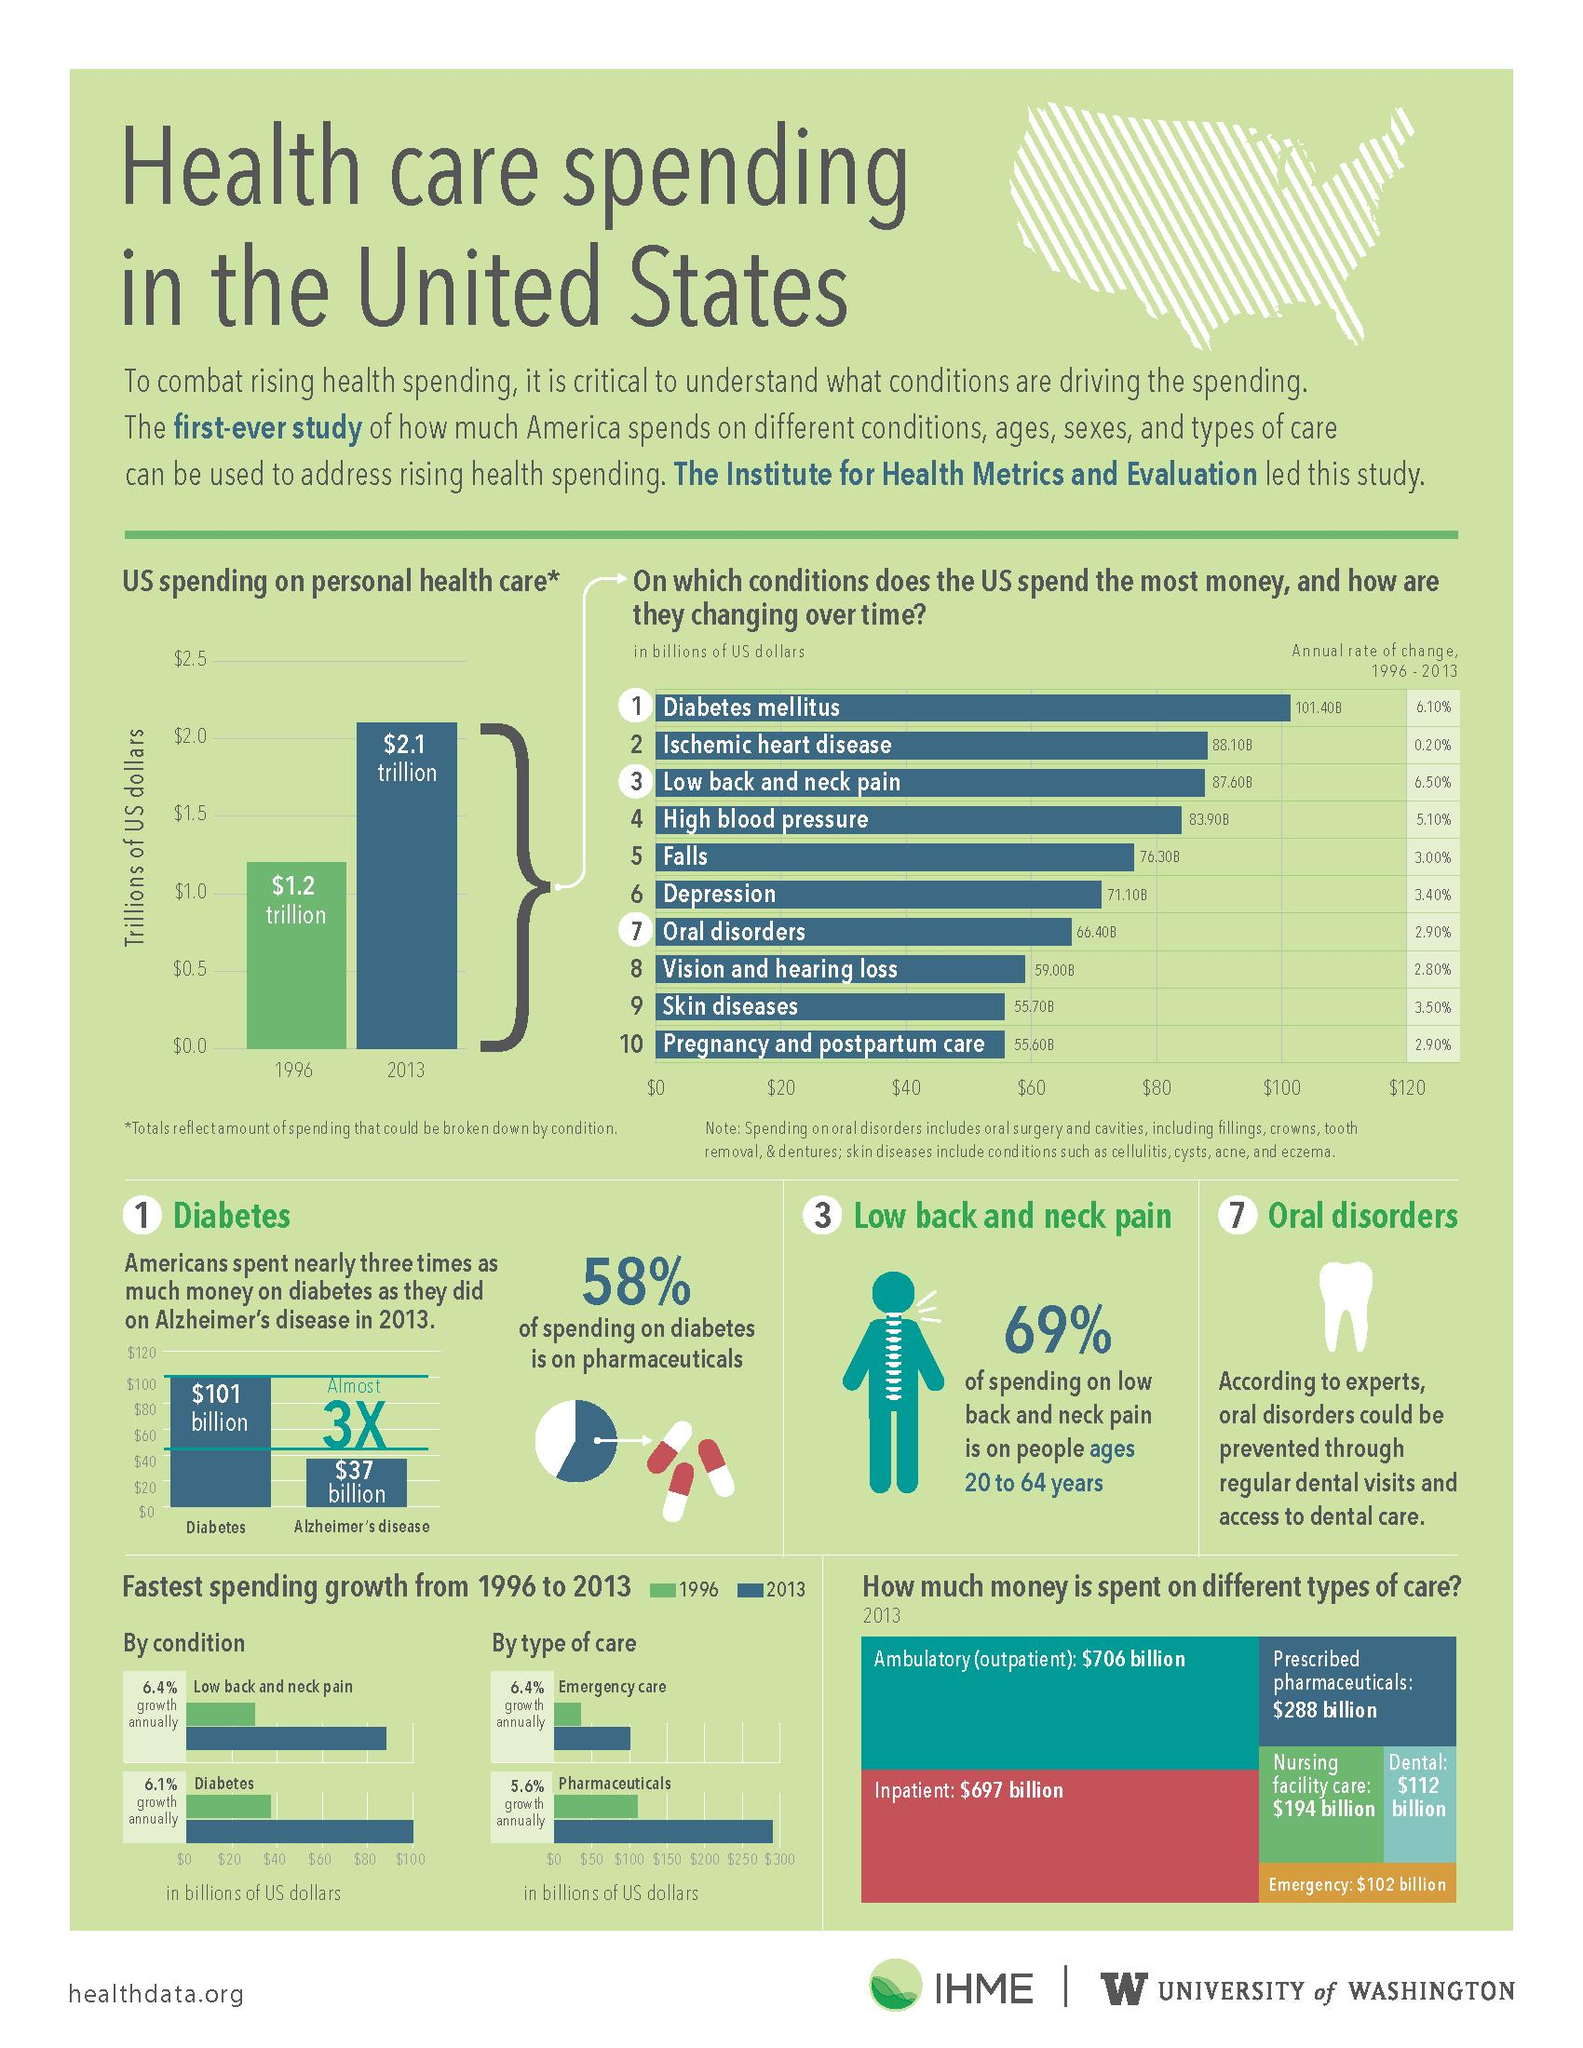Indicate a few pertinent items in this graphic. During the period from 1996 to 2013, the United States spent the most money on diabetes mellitus. During the period from 1996 to 2013, the U.S. spent the least amount of money on pregnancy and postpartum care. In the United States in 2013, a total of $194 billion was spent on nursing facility care. In 2013, the United States spent approximately $102 billion on emergency care. In 2013, Americans spent $37 billion on Alzheimer's disease, a significant amount of money that reflects the significant impact of this disease on society. 